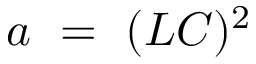Convert formula to latex. <formula><loc_0><loc_0><loc_500><loc_500>a = ( L C ) ^ { 2 }</formula> 